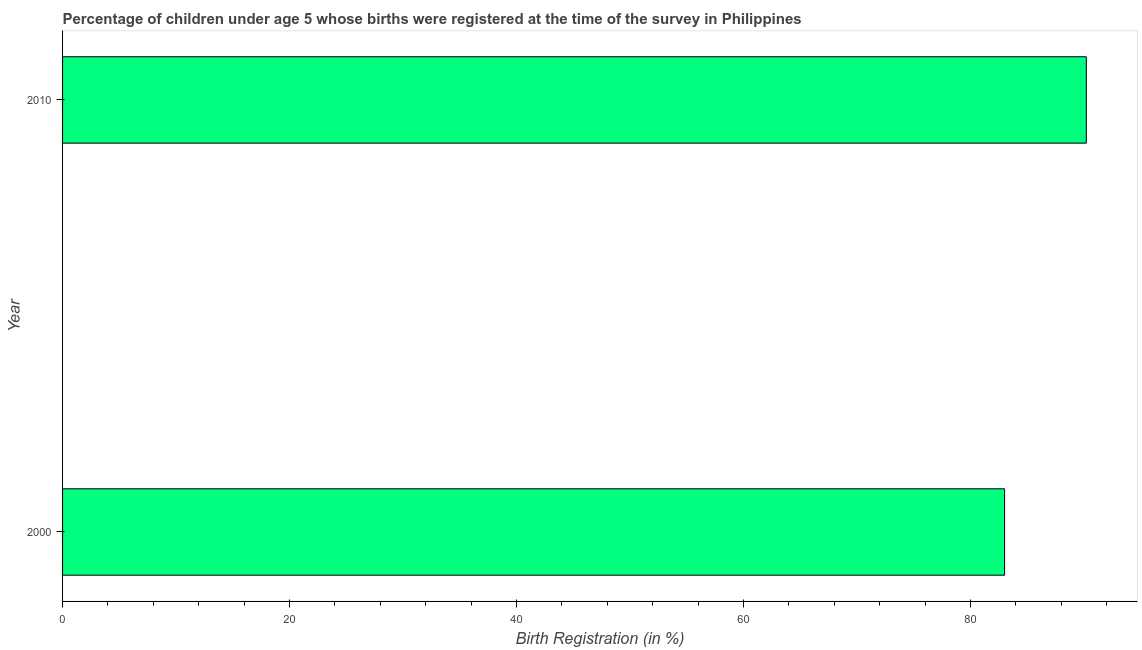Does the graph contain grids?
Offer a very short reply. No. What is the title of the graph?
Your response must be concise. Percentage of children under age 5 whose births were registered at the time of the survey in Philippines. What is the label or title of the X-axis?
Offer a terse response. Birth Registration (in %). What is the label or title of the Y-axis?
Offer a very short reply. Year. Across all years, what is the maximum birth registration?
Provide a succinct answer. 90.2. In which year was the birth registration minimum?
Give a very brief answer. 2000. What is the sum of the birth registration?
Your answer should be very brief. 173.2. What is the average birth registration per year?
Your answer should be compact. 86.6. What is the median birth registration?
Your answer should be very brief. 86.6. Do a majority of the years between 2000 and 2010 (inclusive) have birth registration greater than 8 %?
Give a very brief answer. Yes. How many bars are there?
Offer a very short reply. 2. Are all the bars in the graph horizontal?
Provide a succinct answer. Yes. How many years are there in the graph?
Provide a succinct answer. 2. What is the Birth Registration (in %) of 2010?
Offer a terse response. 90.2. What is the difference between the Birth Registration (in %) in 2000 and 2010?
Make the answer very short. -7.2. 